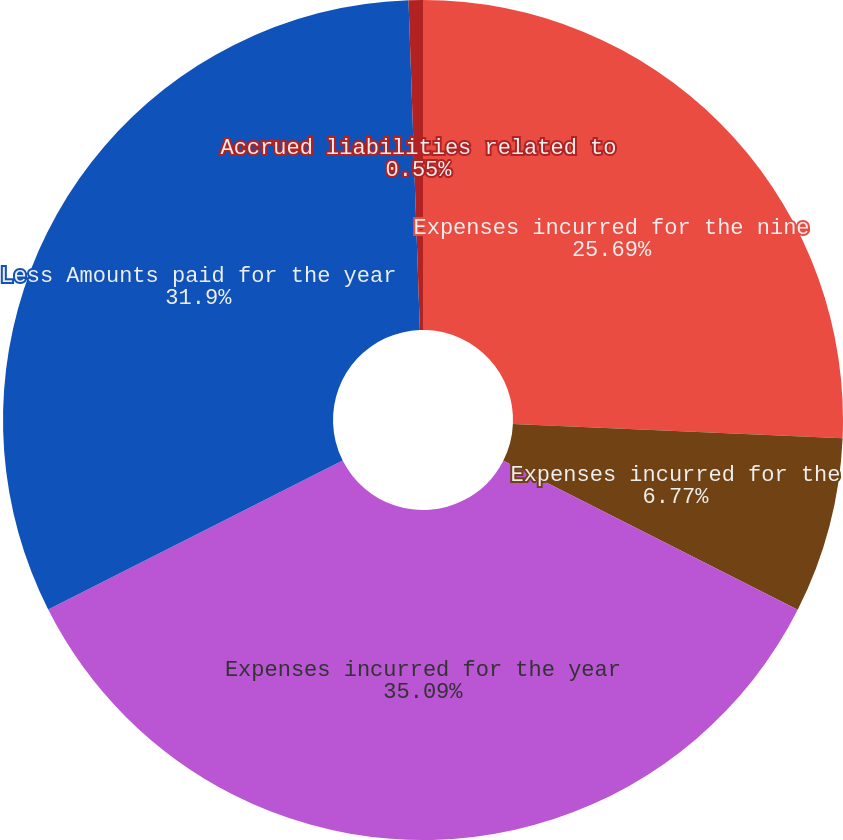Convert chart to OTSL. <chart><loc_0><loc_0><loc_500><loc_500><pie_chart><fcel>Expenses incurred for the nine<fcel>Expenses incurred for the<fcel>Expenses incurred for the year<fcel>Less Amounts paid for the year<fcel>Accrued liabilities related to<nl><fcel>25.69%<fcel>6.77%<fcel>35.09%<fcel>31.9%<fcel>0.55%<nl></chart> 